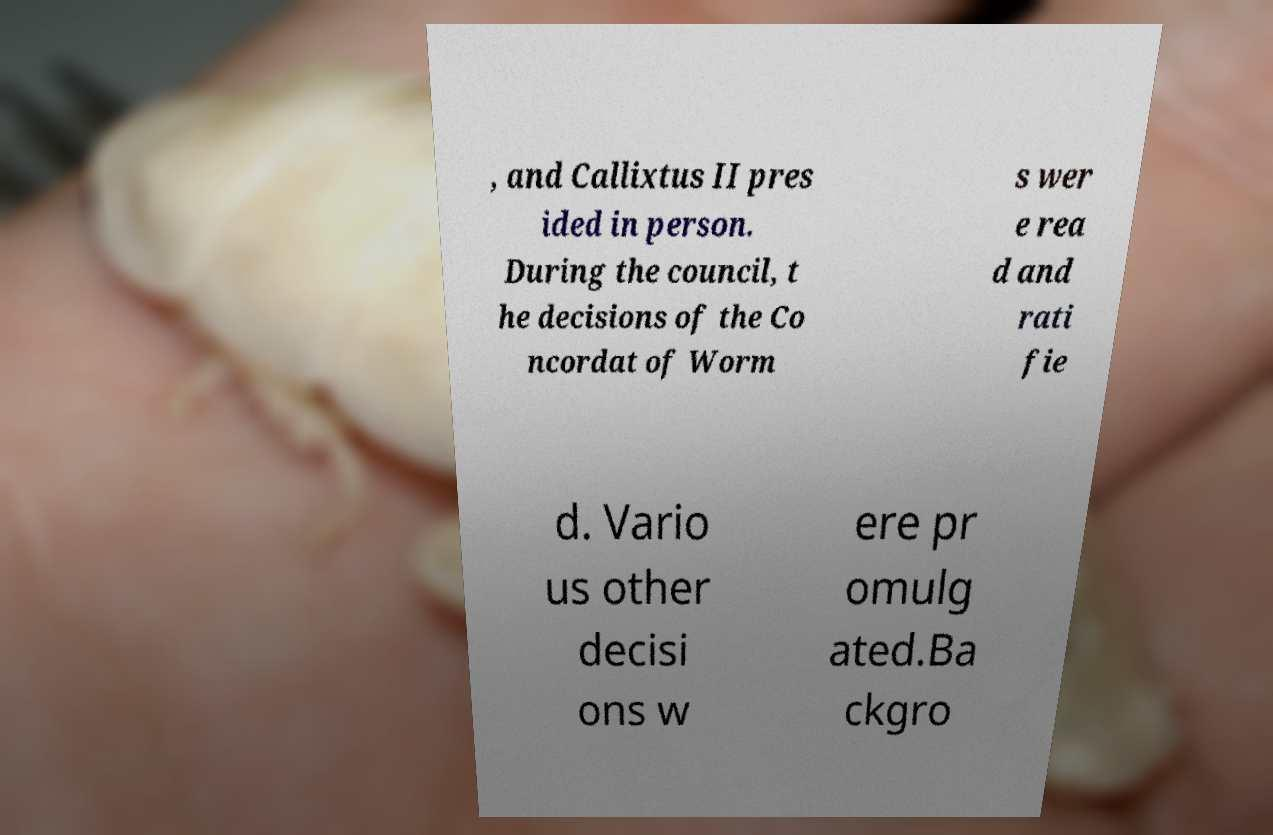I need the written content from this picture converted into text. Can you do that? , and Callixtus II pres ided in person. During the council, t he decisions of the Co ncordat of Worm s wer e rea d and rati fie d. Vario us other decisi ons w ere pr omulg ated.Ba ckgro 